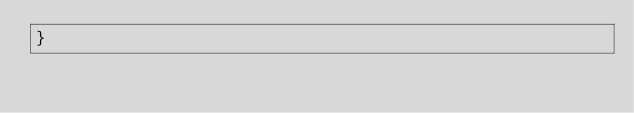Convert code to text. <code><loc_0><loc_0><loc_500><loc_500><_CSS_>}
</code> 